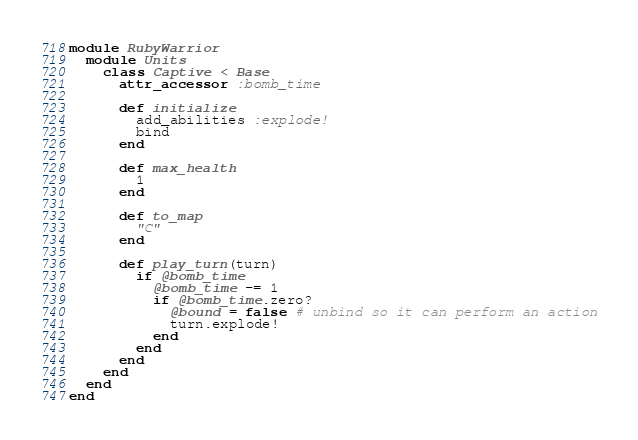<code> <loc_0><loc_0><loc_500><loc_500><_Ruby_>module RubyWarrior
  module Units
    class Captive < Base
      attr_accessor :bomb_time
      
      def initialize
        add_abilities :explode!
        bind
      end
      
      def max_health
        1
      end
      
      def to_map
        "C"
      end
      
      def play_turn(turn)
        if @bomb_time
          @bomb_time -= 1
          if @bomb_time.zero?
            @bound = false # unbind so it can perform an action
            turn.explode!
          end
        end
      end
    end
  end
end
</code> 